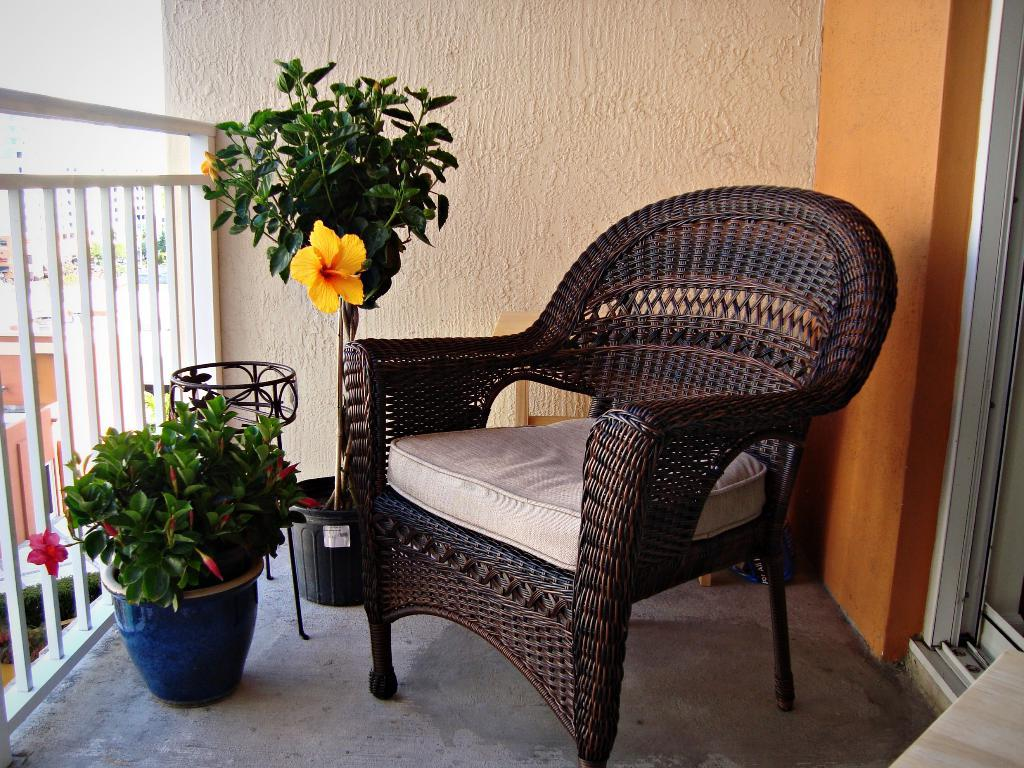What type of furniture is present in the image? There is a chair in the image. What is the tall, three-legged object in the image? There is a tripod in the image. What type of greenery can be seen inside the image? There is a houseplant in the image. What type of greenery can be seen on the path in the image? There is a plant on the path in the image. What can be seen in the distance in the image? There are buildings and trees in the background of the image. What type of letter is being written on the flesh in the image? There is no letter or flesh present in the image. 